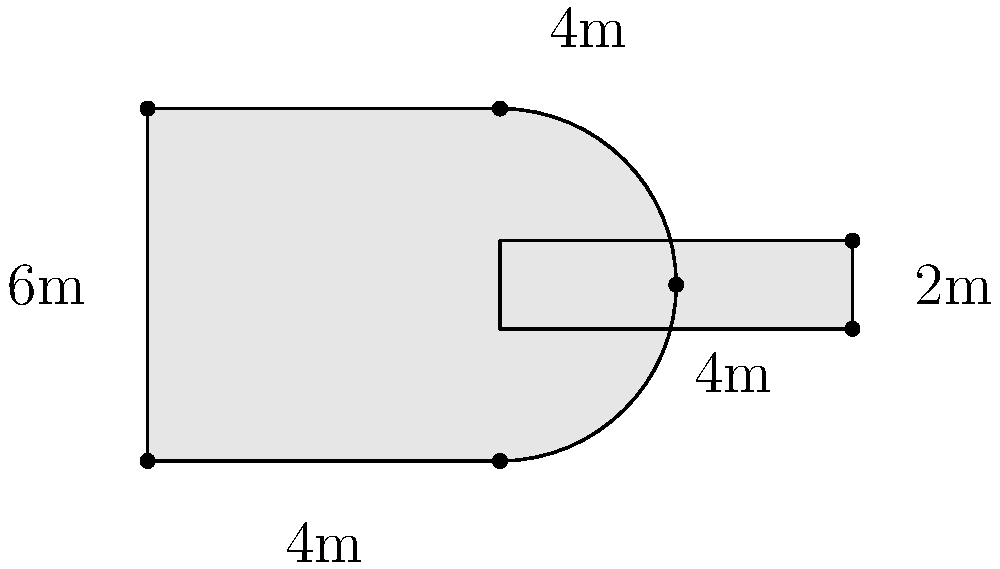For the upcoming school concert, you're designing a guitar-shaped stage. The body of the guitar is approximately rectangular with curved sides, measuring 4m wide and 6m long. The neck of the guitar extends 4m from the body and is 1m wide. What is the perimeter of the entire guitar-shaped stage? Let's break this down step-by-step:

1) First, let's calculate the perimeter of the guitar body:
   - The top and bottom are each 4m long
   - The sides are each 6m long
   - So the basic rectangle perimeter is: $2(4m + 6m) = 20m$
   
2) However, the sides are curved, which will add a bit to the perimeter. We can estimate this additional length as approximately 1m for each side.
   So, we add: $2 * 1m = 2m$

3) Now for the neck:
   - The neck extends 4m from the body
   - It's 1m wide
   - So it adds to the perimeter: $4m + 1m + 4m = 9m$
   
4) Let's sum it all up:
   Guitar body perimeter: $20m + 2m = 22m$
   Neck addition: $9m$
   
5) Total perimeter: $22m + 9m = 31m$

Therefore, the perimeter of the entire guitar-shaped stage is approximately 31 meters.
Answer: 31 meters 